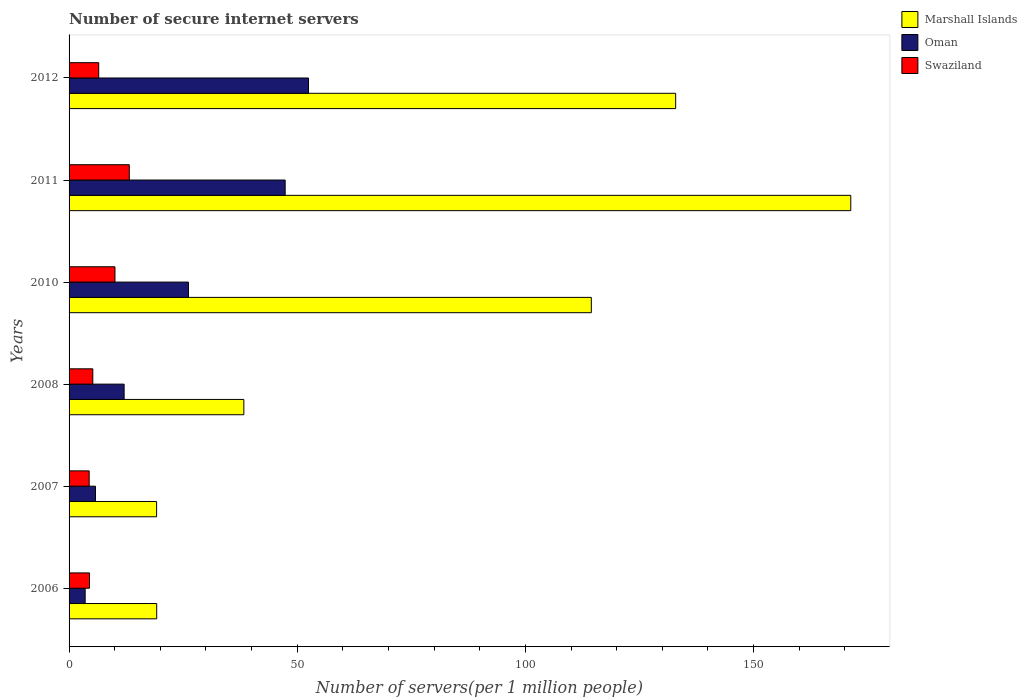How many bars are there on the 3rd tick from the top?
Your response must be concise. 3. What is the label of the 2nd group of bars from the top?
Offer a terse response. 2011. In how many cases, is the number of bars for a given year not equal to the number of legend labels?
Offer a very short reply. 0. What is the number of secure internet servers in Oman in 2012?
Your answer should be compact. 52.47. Across all years, what is the maximum number of secure internet servers in Marshall Islands?
Offer a terse response. 171.29. Across all years, what is the minimum number of secure internet servers in Swaziland?
Offer a very short reply. 4.41. What is the total number of secure internet servers in Marshall Islands in the graph?
Offer a very short reply. 495.34. What is the difference between the number of secure internet servers in Marshall Islands in 2010 and that in 2012?
Your answer should be compact. -18.48. What is the difference between the number of secure internet servers in Swaziland in 2010 and the number of secure internet servers in Marshall Islands in 2008?
Ensure brevity in your answer.  -28.24. What is the average number of secure internet servers in Marshall Islands per year?
Ensure brevity in your answer.  82.56. In the year 2006, what is the difference between the number of secure internet servers in Swaziland and number of secure internet servers in Marshall Islands?
Give a very brief answer. -14.73. What is the ratio of the number of secure internet servers in Oman in 2007 to that in 2011?
Your response must be concise. 0.12. Is the difference between the number of secure internet servers in Swaziland in 2008 and 2011 greater than the difference between the number of secure internet servers in Marshall Islands in 2008 and 2011?
Offer a terse response. Yes. What is the difference between the highest and the second highest number of secure internet servers in Swaziland?
Give a very brief answer. 3.14. What is the difference between the highest and the lowest number of secure internet servers in Oman?
Provide a succinct answer. 48.94. Is the sum of the number of secure internet servers in Oman in 2008 and 2012 greater than the maximum number of secure internet servers in Marshall Islands across all years?
Give a very brief answer. No. What does the 1st bar from the top in 2012 represents?
Your response must be concise. Swaziland. What does the 3rd bar from the bottom in 2010 represents?
Offer a terse response. Swaziland. Is it the case that in every year, the sum of the number of secure internet servers in Marshall Islands and number of secure internet servers in Oman is greater than the number of secure internet servers in Swaziland?
Your response must be concise. Yes. How many years are there in the graph?
Make the answer very short. 6. What is the difference between two consecutive major ticks on the X-axis?
Provide a succinct answer. 50. Does the graph contain any zero values?
Provide a short and direct response. No. How are the legend labels stacked?
Your answer should be very brief. Vertical. What is the title of the graph?
Offer a very short reply. Number of secure internet servers. What is the label or title of the X-axis?
Keep it short and to the point. Number of servers(per 1 million people). What is the label or title of the Y-axis?
Make the answer very short. Years. What is the Number of servers(per 1 million people) in Marshall Islands in 2006?
Your answer should be very brief. 19.2. What is the Number of servers(per 1 million people) in Oman in 2006?
Offer a terse response. 3.52. What is the Number of servers(per 1 million people) of Swaziland in 2006?
Offer a terse response. 4.47. What is the Number of servers(per 1 million people) in Marshall Islands in 2007?
Your answer should be compact. 19.18. What is the Number of servers(per 1 million people) of Oman in 2007?
Provide a short and direct response. 5.78. What is the Number of servers(per 1 million people) in Swaziland in 2007?
Keep it short and to the point. 4.41. What is the Number of servers(per 1 million people) of Marshall Islands in 2008?
Your answer should be compact. 38.3. What is the Number of servers(per 1 million people) of Oman in 2008?
Keep it short and to the point. 12.07. What is the Number of servers(per 1 million people) in Swaziland in 2008?
Your answer should be very brief. 5.2. What is the Number of servers(per 1 million people) in Marshall Islands in 2010?
Ensure brevity in your answer.  114.44. What is the Number of servers(per 1 million people) in Oman in 2010?
Your answer should be very brief. 26.16. What is the Number of servers(per 1 million people) in Swaziland in 2010?
Provide a succinct answer. 10.06. What is the Number of servers(per 1 million people) in Marshall Islands in 2011?
Offer a terse response. 171.29. What is the Number of servers(per 1 million people) in Oman in 2011?
Provide a short and direct response. 47.35. What is the Number of servers(per 1 million people) in Swaziland in 2011?
Your answer should be compact. 13.2. What is the Number of servers(per 1 million people) of Marshall Islands in 2012?
Give a very brief answer. 132.92. What is the Number of servers(per 1 million people) of Oman in 2012?
Make the answer very short. 52.47. What is the Number of servers(per 1 million people) in Swaziland in 2012?
Offer a very short reply. 6.5. Across all years, what is the maximum Number of servers(per 1 million people) of Marshall Islands?
Your answer should be very brief. 171.29. Across all years, what is the maximum Number of servers(per 1 million people) in Oman?
Make the answer very short. 52.47. Across all years, what is the maximum Number of servers(per 1 million people) in Swaziland?
Keep it short and to the point. 13.2. Across all years, what is the minimum Number of servers(per 1 million people) in Marshall Islands?
Your answer should be compact. 19.18. Across all years, what is the minimum Number of servers(per 1 million people) of Oman?
Give a very brief answer. 3.52. Across all years, what is the minimum Number of servers(per 1 million people) of Swaziland?
Keep it short and to the point. 4.41. What is the total Number of servers(per 1 million people) of Marshall Islands in the graph?
Keep it short and to the point. 495.34. What is the total Number of servers(per 1 million people) of Oman in the graph?
Give a very brief answer. 147.35. What is the total Number of servers(per 1 million people) of Swaziland in the graph?
Provide a succinct answer. 43.83. What is the difference between the Number of servers(per 1 million people) in Marshall Islands in 2006 and that in 2007?
Your answer should be very brief. 0.02. What is the difference between the Number of servers(per 1 million people) in Oman in 2006 and that in 2007?
Offer a terse response. -2.26. What is the difference between the Number of servers(per 1 million people) of Swaziland in 2006 and that in 2007?
Your answer should be very brief. 0.07. What is the difference between the Number of servers(per 1 million people) in Marshall Islands in 2006 and that in 2008?
Offer a very short reply. -19.1. What is the difference between the Number of servers(per 1 million people) in Oman in 2006 and that in 2008?
Your response must be concise. -8.54. What is the difference between the Number of servers(per 1 million people) of Swaziland in 2006 and that in 2008?
Your answer should be compact. -0.73. What is the difference between the Number of servers(per 1 million people) in Marshall Islands in 2006 and that in 2010?
Your answer should be compact. -95.24. What is the difference between the Number of servers(per 1 million people) in Oman in 2006 and that in 2010?
Your answer should be very brief. -22.63. What is the difference between the Number of servers(per 1 million people) in Swaziland in 2006 and that in 2010?
Keep it short and to the point. -5.59. What is the difference between the Number of servers(per 1 million people) of Marshall Islands in 2006 and that in 2011?
Make the answer very short. -152.09. What is the difference between the Number of servers(per 1 million people) in Oman in 2006 and that in 2011?
Your response must be concise. -43.83. What is the difference between the Number of servers(per 1 million people) of Swaziland in 2006 and that in 2011?
Provide a short and direct response. -8.72. What is the difference between the Number of servers(per 1 million people) in Marshall Islands in 2006 and that in 2012?
Give a very brief answer. -113.72. What is the difference between the Number of servers(per 1 million people) of Oman in 2006 and that in 2012?
Ensure brevity in your answer.  -48.94. What is the difference between the Number of servers(per 1 million people) of Swaziland in 2006 and that in 2012?
Keep it short and to the point. -2.02. What is the difference between the Number of servers(per 1 million people) of Marshall Islands in 2007 and that in 2008?
Offer a very short reply. -19.12. What is the difference between the Number of servers(per 1 million people) in Oman in 2007 and that in 2008?
Your answer should be very brief. -6.28. What is the difference between the Number of servers(per 1 million people) in Swaziland in 2007 and that in 2008?
Keep it short and to the point. -0.79. What is the difference between the Number of servers(per 1 million people) of Marshall Islands in 2007 and that in 2010?
Your response must be concise. -95.26. What is the difference between the Number of servers(per 1 million people) in Oman in 2007 and that in 2010?
Offer a terse response. -20.37. What is the difference between the Number of servers(per 1 million people) in Swaziland in 2007 and that in 2010?
Provide a succinct answer. -5.65. What is the difference between the Number of servers(per 1 million people) in Marshall Islands in 2007 and that in 2011?
Offer a very short reply. -152.11. What is the difference between the Number of servers(per 1 million people) in Oman in 2007 and that in 2011?
Give a very brief answer. -41.57. What is the difference between the Number of servers(per 1 million people) in Swaziland in 2007 and that in 2011?
Provide a succinct answer. -8.79. What is the difference between the Number of servers(per 1 million people) of Marshall Islands in 2007 and that in 2012?
Keep it short and to the point. -113.74. What is the difference between the Number of servers(per 1 million people) in Oman in 2007 and that in 2012?
Your answer should be compact. -46.68. What is the difference between the Number of servers(per 1 million people) of Swaziland in 2007 and that in 2012?
Keep it short and to the point. -2.09. What is the difference between the Number of servers(per 1 million people) of Marshall Islands in 2008 and that in 2010?
Your answer should be compact. -76.14. What is the difference between the Number of servers(per 1 million people) of Oman in 2008 and that in 2010?
Your answer should be very brief. -14.09. What is the difference between the Number of servers(per 1 million people) in Swaziland in 2008 and that in 2010?
Provide a short and direct response. -4.86. What is the difference between the Number of servers(per 1 million people) of Marshall Islands in 2008 and that in 2011?
Provide a short and direct response. -133. What is the difference between the Number of servers(per 1 million people) of Oman in 2008 and that in 2011?
Your response must be concise. -35.29. What is the difference between the Number of servers(per 1 million people) of Swaziland in 2008 and that in 2011?
Offer a very short reply. -8. What is the difference between the Number of servers(per 1 million people) of Marshall Islands in 2008 and that in 2012?
Provide a short and direct response. -94.62. What is the difference between the Number of servers(per 1 million people) of Oman in 2008 and that in 2012?
Provide a short and direct response. -40.4. What is the difference between the Number of servers(per 1 million people) of Swaziland in 2008 and that in 2012?
Provide a succinct answer. -1.29. What is the difference between the Number of servers(per 1 million people) in Marshall Islands in 2010 and that in 2011?
Ensure brevity in your answer.  -56.85. What is the difference between the Number of servers(per 1 million people) of Oman in 2010 and that in 2011?
Your response must be concise. -21.19. What is the difference between the Number of servers(per 1 million people) of Swaziland in 2010 and that in 2011?
Your answer should be very brief. -3.14. What is the difference between the Number of servers(per 1 million people) in Marshall Islands in 2010 and that in 2012?
Offer a very short reply. -18.48. What is the difference between the Number of servers(per 1 million people) in Oman in 2010 and that in 2012?
Give a very brief answer. -26.31. What is the difference between the Number of servers(per 1 million people) of Swaziland in 2010 and that in 2012?
Ensure brevity in your answer.  3.56. What is the difference between the Number of servers(per 1 million people) of Marshall Islands in 2011 and that in 2012?
Your response must be concise. 38.37. What is the difference between the Number of servers(per 1 million people) in Oman in 2011 and that in 2012?
Your response must be concise. -5.11. What is the difference between the Number of servers(per 1 million people) in Swaziland in 2011 and that in 2012?
Make the answer very short. 6.7. What is the difference between the Number of servers(per 1 million people) of Marshall Islands in 2006 and the Number of servers(per 1 million people) of Oman in 2007?
Offer a very short reply. 13.42. What is the difference between the Number of servers(per 1 million people) of Marshall Islands in 2006 and the Number of servers(per 1 million people) of Swaziland in 2007?
Provide a short and direct response. 14.8. What is the difference between the Number of servers(per 1 million people) of Oman in 2006 and the Number of servers(per 1 million people) of Swaziland in 2007?
Offer a very short reply. -0.88. What is the difference between the Number of servers(per 1 million people) of Marshall Islands in 2006 and the Number of servers(per 1 million people) of Oman in 2008?
Give a very brief answer. 7.14. What is the difference between the Number of servers(per 1 million people) in Marshall Islands in 2006 and the Number of servers(per 1 million people) in Swaziland in 2008?
Keep it short and to the point. 14. What is the difference between the Number of servers(per 1 million people) in Oman in 2006 and the Number of servers(per 1 million people) in Swaziland in 2008?
Keep it short and to the point. -1.68. What is the difference between the Number of servers(per 1 million people) of Marshall Islands in 2006 and the Number of servers(per 1 million people) of Oman in 2010?
Keep it short and to the point. -6.96. What is the difference between the Number of servers(per 1 million people) in Marshall Islands in 2006 and the Number of servers(per 1 million people) in Swaziland in 2010?
Make the answer very short. 9.14. What is the difference between the Number of servers(per 1 million people) in Oman in 2006 and the Number of servers(per 1 million people) in Swaziland in 2010?
Make the answer very short. -6.53. What is the difference between the Number of servers(per 1 million people) in Marshall Islands in 2006 and the Number of servers(per 1 million people) in Oman in 2011?
Your answer should be very brief. -28.15. What is the difference between the Number of servers(per 1 million people) in Marshall Islands in 2006 and the Number of servers(per 1 million people) in Swaziland in 2011?
Keep it short and to the point. 6. What is the difference between the Number of servers(per 1 million people) of Oman in 2006 and the Number of servers(per 1 million people) of Swaziland in 2011?
Your answer should be compact. -9.67. What is the difference between the Number of servers(per 1 million people) in Marshall Islands in 2006 and the Number of servers(per 1 million people) in Oman in 2012?
Make the answer very short. -33.26. What is the difference between the Number of servers(per 1 million people) of Marshall Islands in 2006 and the Number of servers(per 1 million people) of Swaziland in 2012?
Provide a short and direct response. 12.71. What is the difference between the Number of servers(per 1 million people) of Oman in 2006 and the Number of servers(per 1 million people) of Swaziland in 2012?
Your answer should be very brief. -2.97. What is the difference between the Number of servers(per 1 million people) in Marshall Islands in 2007 and the Number of servers(per 1 million people) in Oman in 2008?
Offer a very short reply. 7.12. What is the difference between the Number of servers(per 1 million people) of Marshall Islands in 2007 and the Number of servers(per 1 million people) of Swaziland in 2008?
Offer a terse response. 13.98. What is the difference between the Number of servers(per 1 million people) of Oman in 2007 and the Number of servers(per 1 million people) of Swaziland in 2008?
Provide a short and direct response. 0.58. What is the difference between the Number of servers(per 1 million people) of Marshall Islands in 2007 and the Number of servers(per 1 million people) of Oman in 2010?
Offer a terse response. -6.98. What is the difference between the Number of servers(per 1 million people) of Marshall Islands in 2007 and the Number of servers(per 1 million people) of Swaziland in 2010?
Your answer should be very brief. 9.12. What is the difference between the Number of servers(per 1 million people) of Oman in 2007 and the Number of servers(per 1 million people) of Swaziland in 2010?
Provide a succinct answer. -4.27. What is the difference between the Number of servers(per 1 million people) in Marshall Islands in 2007 and the Number of servers(per 1 million people) in Oman in 2011?
Offer a terse response. -28.17. What is the difference between the Number of servers(per 1 million people) in Marshall Islands in 2007 and the Number of servers(per 1 million people) in Swaziland in 2011?
Keep it short and to the point. 5.98. What is the difference between the Number of servers(per 1 million people) in Oman in 2007 and the Number of servers(per 1 million people) in Swaziland in 2011?
Offer a very short reply. -7.41. What is the difference between the Number of servers(per 1 million people) of Marshall Islands in 2007 and the Number of servers(per 1 million people) of Oman in 2012?
Your answer should be compact. -33.28. What is the difference between the Number of servers(per 1 million people) in Marshall Islands in 2007 and the Number of servers(per 1 million people) in Swaziland in 2012?
Offer a terse response. 12.69. What is the difference between the Number of servers(per 1 million people) in Oman in 2007 and the Number of servers(per 1 million people) in Swaziland in 2012?
Offer a very short reply. -0.71. What is the difference between the Number of servers(per 1 million people) of Marshall Islands in 2008 and the Number of servers(per 1 million people) of Oman in 2010?
Ensure brevity in your answer.  12.14. What is the difference between the Number of servers(per 1 million people) in Marshall Islands in 2008 and the Number of servers(per 1 million people) in Swaziland in 2010?
Provide a succinct answer. 28.24. What is the difference between the Number of servers(per 1 million people) in Oman in 2008 and the Number of servers(per 1 million people) in Swaziland in 2010?
Give a very brief answer. 2.01. What is the difference between the Number of servers(per 1 million people) of Marshall Islands in 2008 and the Number of servers(per 1 million people) of Oman in 2011?
Provide a short and direct response. -9.05. What is the difference between the Number of servers(per 1 million people) in Marshall Islands in 2008 and the Number of servers(per 1 million people) in Swaziland in 2011?
Your answer should be very brief. 25.1. What is the difference between the Number of servers(per 1 million people) of Oman in 2008 and the Number of servers(per 1 million people) of Swaziland in 2011?
Give a very brief answer. -1.13. What is the difference between the Number of servers(per 1 million people) in Marshall Islands in 2008 and the Number of servers(per 1 million people) in Oman in 2012?
Provide a succinct answer. -14.17. What is the difference between the Number of servers(per 1 million people) in Marshall Islands in 2008 and the Number of servers(per 1 million people) in Swaziland in 2012?
Your answer should be compact. 31.8. What is the difference between the Number of servers(per 1 million people) of Oman in 2008 and the Number of servers(per 1 million people) of Swaziland in 2012?
Give a very brief answer. 5.57. What is the difference between the Number of servers(per 1 million people) of Marshall Islands in 2010 and the Number of servers(per 1 million people) of Oman in 2011?
Ensure brevity in your answer.  67.09. What is the difference between the Number of servers(per 1 million people) of Marshall Islands in 2010 and the Number of servers(per 1 million people) of Swaziland in 2011?
Offer a very short reply. 101.25. What is the difference between the Number of servers(per 1 million people) in Oman in 2010 and the Number of servers(per 1 million people) in Swaziland in 2011?
Ensure brevity in your answer.  12.96. What is the difference between the Number of servers(per 1 million people) in Marshall Islands in 2010 and the Number of servers(per 1 million people) in Oman in 2012?
Provide a short and direct response. 61.98. What is the difference between the Number of servers(per 1 million people) in Marshall Islands in 2010 and the Number of servers(per 1 million people) in Swaziland in 2012?
Ensure brevity in your answer.  107.95. What is the difference between the Number of servers(per 1 million people) of Oman in 2010 and the Number of servers(per 1 million people) of Swaziland in 2012?
Keep it short and to the point. 19.66. What is the difference between the Number of servers(per 1 million people) in Marshall Islands in 2011 and the Number of servers(per 1 million people) in Oman in 2012?
Your answer should be very brief. 118.83. What is the difference between the Number of servers(per 1 million people) in Marshall Islands in 2011 and the Number of servers(per 1 million people) in Swaziland in 2012?
Ensure brevity in your answer.  164.8. What is the difference between the Number of servers(per 1 million people) of Oman in 2011 and the Number of servers(per 1 million people) of Swaziland in 2012?
Provide a succinct answer. 40.86. What is the average Number of servers(per 1 million people) of Marshall Islands per year?
Your answer should be very brief. 82.56. What is the average Number of servers(per 1 million people) in Oman per year?
Keep it short and to the point. 24.56. What is the average Number of servers(per 1 million people) of Swaziland per year?
Make the answer very short. 7.3. In the year 2006, what is the difference between the Number of servers(per 1 million people) of Marshall Islands and Number of servers(per 1 million people) of Oman?
Offer a terse response. 15.68. In the year 2006, what is the difference between the Number of servers(per 1 million people) of Marshall Islands and Number of servers(per 1 million people) of Swaziland?
Your answer should be compact. 14.73. In the year 2006, what is the difference between the Number of servers(per 1 million people) in Oman and Number of servers(per 1 million people) in Swaziland?
Ensure brevity in your answer.  -0.95. In the year 2007, what is the difference between the Number of servers(per 1 million people) in Marshall Islands and Number of servers(per 1 million people) in Oman?
Keep it short and to the point. 13.4. In the year 2007, what is the difference between the Number of servers(per 1 million people) of Marshall Islands and Number of servers(per 1 million people) of Swaziland?
Your response must be concise. 14.77. In the year 2007, what is the difference between the Number of servers(per 1 million people) of Oman and Number of servers(per 1 million people) of Swaziland?
Ensure brevity in your answer.  1.38. In the year 2008, what is the difference between the Number of servers(per 1 million people) of Marshall Islands and Number of servers(per 1 million people) of Oman?
Provide a short and direct response. 26.23. In the year 2008, what is the difference between the Number of servers(per 1 million people) in Marshall Islands and Number of servers(per 1 million people) in Swaziland?
Give a very brief answer. 33.1. In the year 2008, what is the difference between the Number of servers(per 1 million people) in Oman and Number of servers(per 1 million people) in Swaziland?
Your answer should be compact. 6.86. In the year 2010, what is the difference between the Number of servers(per 1 million people) of Marshall Islands and Number of servers(per 1 million people) of Oman?
Your answer should be compact. 88.29. In the year 2010, what is the difference between the Number of servers(per 1 million people) in Marshall Islands and Number of servers(per 1 million people) in Swaziland?
Your answer should be compact. 104.39. In the year 2010, what is the difference between the Number of servers(per 1 million people) in Oman and Number of servers(per 1 million people) in Swaziland?
Your response must be concise. 16.1. In the year 2011, what is the difference between the Number of servers(per 1 million people) in Marshall Islands and Number of servers(per 1 million people) in Oman?
Your response must be concise. 123.94. In the year 2011, what is the difference between the Number of servers(per 1 million people) of Marshall Islands and Number of servers(per 1 million people) of Swaziland?
Your answer should be compact. 158.1. In the year 2011, what is the difference between the Number of servers(per 1 million people) of Oman and Number of servers(per 1 million people) of Swaziland?
Offer a terse response. 34.16. In the year 2012, what is the difference between the Number of servers(per 1 million people) in Marshall Islands and Number of servers(per 1 million people) in Oman?
Give a very brief answer. 80.46. In the year 2012, what is the difference between the Number of servers(per 1 million people) in Marshall Islands and Number of servers(per 1 million people) in Swaziland?
Offer a terse response. 126.43. In the year 2012, what is the difference between the Number of servers(per 1 million people) in Oman and Number of servers(per 1 million people) in Swaziland?
Your answer should be very brief. 45.97. What is the ratio of the Number of servers(per 1 million people) of Marshall Islands in 2006 to that in 2007?
Provide a short and direct response. 1. What is the ratio of the Number of servers(per 1 million people) of Oman in 2006 to that in 2007?
Keep it short and to the point. 0.61. What is the ratio of the Number of servers(per 1 million people) in Swaziland in 2006 to that in 2007?
Keep it short and to the point. 1.01. What is the ratio of the Number of servers(per 1 million people) in Marshall Islands in 2006 to that in 2008?
Your response must be concise. 0.5. What is the ratio of the Number of servers(per 1 million people) of Oman in 2006 to that in 2008?
Ensure brevity in your answer.  0.29. What is the ratio of the Number of servers(per 1 million people) of Swaziland in 2006 to that in 2008?
Give a very brief answer. 0.86. What is the ratio of the Number of servers(per 1 million people) in Marshall Islands in 2006 to that in 2010?
Offer a very short reply. 0.17. What is the ratio of the Number of servers(per 1 million people) of Oman in 2006 to that in 2010?
Offer a very short reply. 0.13. What is the ratio of the Number of servers(per 1 million people) in Swaziland in 2006 to that in 2010?
Provide a succinct answer. 0.44. What is the ratio of the Number of servers(per 1 million people) in Marshall Islands in 2006 to that in 2011?
Offer a very short reply. 0.11. What is the ratio of the Number of servers(per 1 million people) in Oman in 2006 to that in 2011?
Make the answer very short. 0.07. What is the ratio of the Number of servers(per 1 million people) of Swaziland in 2006 to that in 2011?
Your answer should be very brief. 0.34. What is the ratio of the Number of servers(per 1 million people) of Marshall Islands in 2006 to that in 2012?
Ensure brevity in your answer.  0.14. What is the ratio of the Number of servers(per 1 million people) in Oman in 2006 to that in 2012?
Offer a terse response. 0.07. What is the ratio of the Number of servers(per 1 million people) of Swaziland in 2006 to that in 2012?
Your response must be concise. 0.69. What is the ratio of the Number of servers(per 1 million people) of Marshall Islands in 2007 to that in 2008?
Keep it short and to the point. 0.5. What is the ratio of the Number of servers(per 1 million people) of Oman in 2007 to that in 2008?
Keep it short and to the point. 0.48. What is the ratio of the Number of servers(per 1 million people) in Swaziland in 2007 to that in 2008?
Offer a terse response. 0.85. What is the ratio of the Number of servers(per 1 million people) in Marshall Islands in 2007 to that in 2010?
Offer a terse response. 0.17. What is the ratio of the Number of servers(per 1 million people) of Oman in 2007 to that in 2010?
Provide a short and direct response. 0.22. What is the ratio of the Number of servers(per 1 million people) of Swaziland in 2007 to that in 2010?
Make the answer very short. 0.44. What is the ratio of the Number of servers(per 1 million people) in Marshall Islands in 2007 to that in 2011?
Give a very brief answer. 0.11. What is the ratio of the Number of servers(per 1 million people) of Oman in 2007 to that in 2011?
Offer a terse response. 0.12. What is the ratio of the Number of servers(per 1 million people) in Swaziland in 2007 to that in 2011?
Provide a succinct answer. 0.33. What is the ratio of the Number of servers(per 1 million people) of Marshall Islands in 2007 to that in 2012?
Offer a very short reply. 0.14. What is the ratio of the Number of servers(per 1 million people) in Oman in 2007 to that in 2012?
Offer a very short reply. 0.11. What is the ratio of the Number of servers(per 1 million people) of Swaziland in 2007 to that in 2012?
Make the answer very short. 0.68. What is the ratio of the Number of servers(per 1 million people) in Marshall Islands in 2008 to that in 2010?
Ensure brevity in your answer.  0.33. What is the ratio of the Number of servers(per 1 million people) in Oman in 2008 to that in 2010?
Offer a terse response. 0.46. What is the ratio of the Number of servers(per 1 million people) of Swaziland in 2008 to that in 2010?
Your answer should be very brief. 0.52. What is the ratio of the Number of servers(per 1 million people) in Marshall Islands in 2008 to that in 2011?
Your response must be concise. 0.22. What is the ratio of the Number of servers(per 1 million people) in Oman in 2008 to that in 2011?
Offer a very short reply. 0.25. What is the ratio of the Number of servers(per 1 million people) of Swaziland in 2008 to that in 2011?
Keep it short and to the point. 0.39. What is the ratio of the Number of servers(per 1 million people) in Marshall Islands in 2008 to that in 2012?
Ensure brevity in your answer.  0.29. What is the ratio of the Number of servers(per 1 million people) of Oman in 2008 to that in 2012?
Your response must be concise. 0.23. What is the ratio of the Number of servers(per 1 million people) in Swaziland in 2008 to that in 2012?
Offer a very short reply. 0.8. What is the ratio of the Number of servers(per 1 million people) in Marshall Islands in 2010 to that in 2011?
Your answer should be very brief. 0.67. What is the ratio of the Number of servers(per 1 million people) in Oman in 2010 to that in 2011?
Your answer should be compact. 0.55. What is the ratio of the Number of servers(per 1 million people) of Swaziland in 2010 to that in 2011?
Your answer should be compact. 0.76. What is the ratio of the Number of servers(per 1 million people) of Marshall Islands in 2010 to that in 2012?
Make the answer very short. 0.86. What is the ratio of the Number of servers(per 1 million people) in Oman in 2010 to that in 2012?
Your answer should be very brief. 0.5. What is the ratio of the Number of servers(per 1 million people) in Swaziland in 2010 to that in 2012?
Your answer should be compact. 1.55. What is the ratio of the Number of servers(per 1 million people) in Marshall Islands in 2011 to that in 2012?
Your answer should be compact. 1.29. What is the ratio of the Number of servers(per 1 million people) of Oman in 2011 to that in 2012?
Give a very brief answer. 0.9. What is the ratio of the Number of servers(per 1 million people) in Swaziland in 2011 to that in 2012?
Ensure brevity in your answer.  2.03. What is the difference between the highest and the second highest Number of servers(per 1 million people) of Marshall Islands?
Your answer should be very brief. 38.37. What is the difference between the highest and the second highest Number of servers(per 1 million people) of Oman?
Give a very brief answer. 5.11. What is the difference between the highest and the second highest Number of servers(per 1 million people) in Swaziland?
Your answer should be compact. 3.14. What is the difference between the highest and the lowest Number of servers(per 1 million people) in Marshall Islands?
Keep it short and to the point. 152.11. What is the difference between the highest and the lowest Number of servers(per 1 million people) of Oman?
Your response must be concise. 48.94. What is the difference between the highest and the lowest Number of servers(per 1 million people) in Swaziland?
Ensure brevity in your answer.  8.79. 